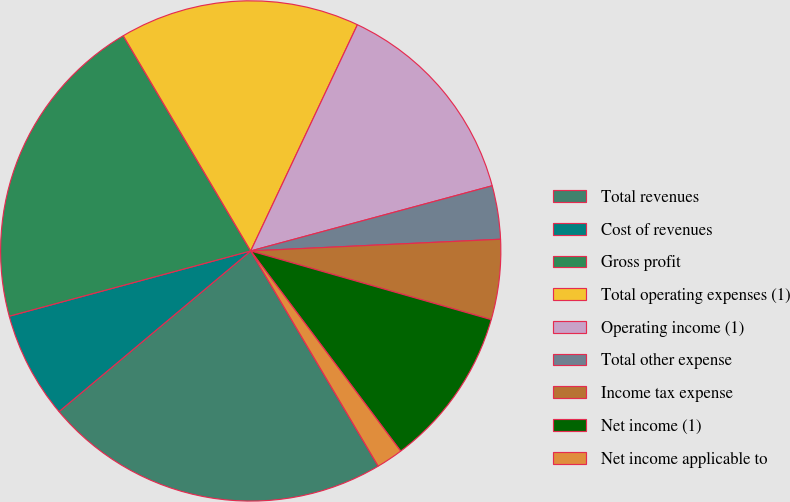Convert chart to OTSL. <chart><loc_0><loc_0><loc_500><loc_500><pie_chart><fcel>Total revenues<fcel>Cost of revenues<fcel>Gross profit<fcel>Total operating expenses (1)<fcel>Operating income (1)<fcel>Total other expense<fcel>Income tax expense<fcel>Net income (1)<fcel>Net income applicable to<nl><fcel>22.41%<fcel>6.9%<fcel>20.69%<fcel>15.52%<fcel>13.79%<fcel>3.45%<fcel>5.17%<fcel>10.34%<fcel>1.72%<nl></chart> 